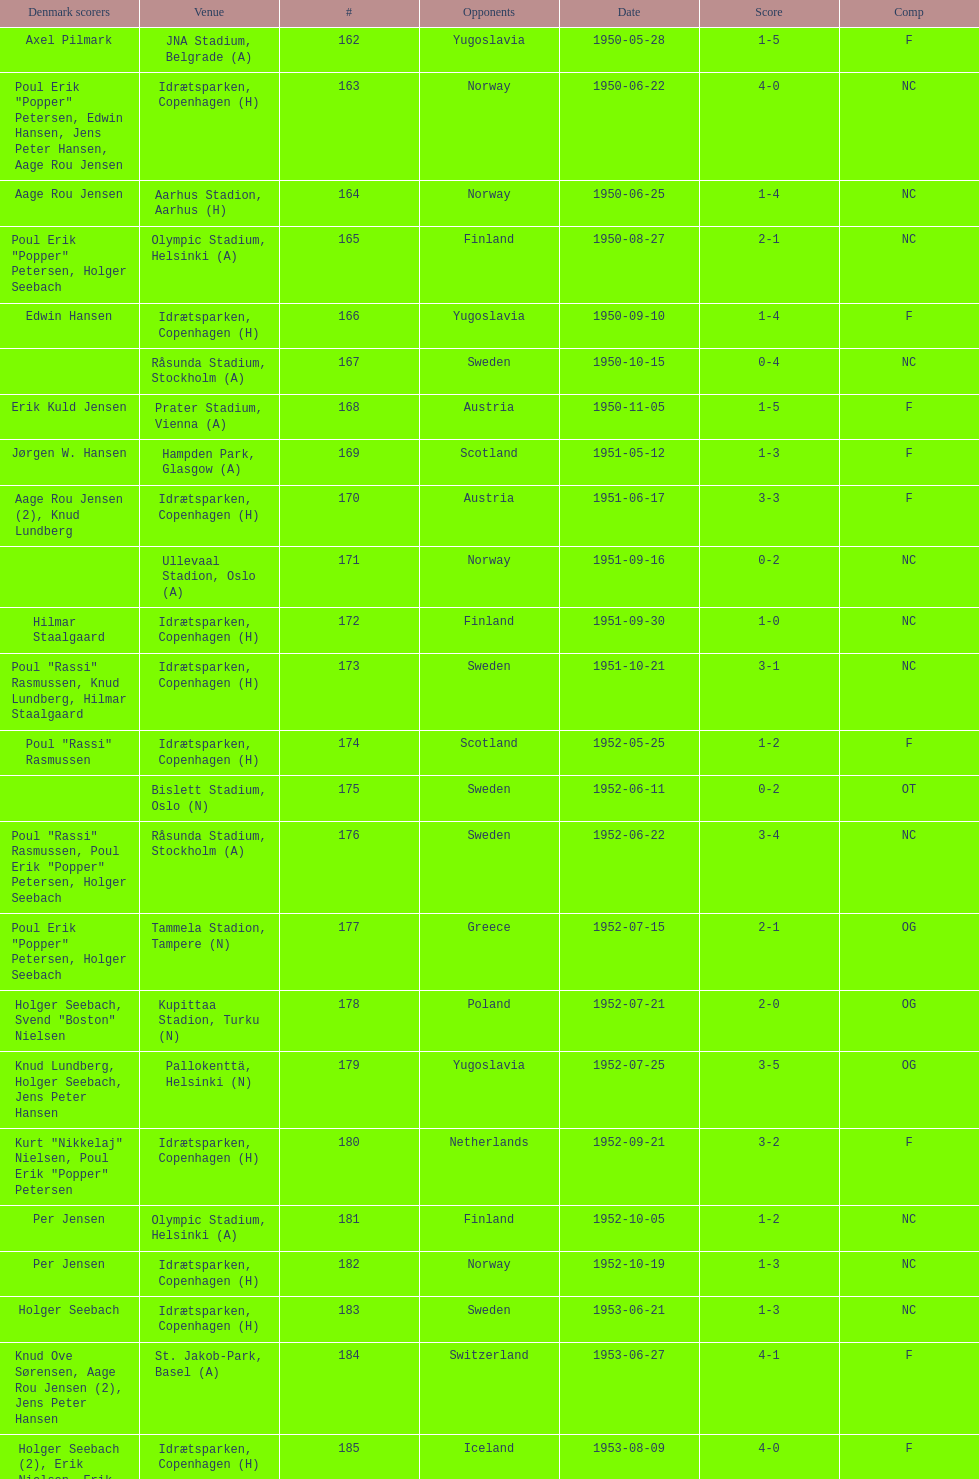Who did they play in the game listed directly above july 25, 1952? Poland. 